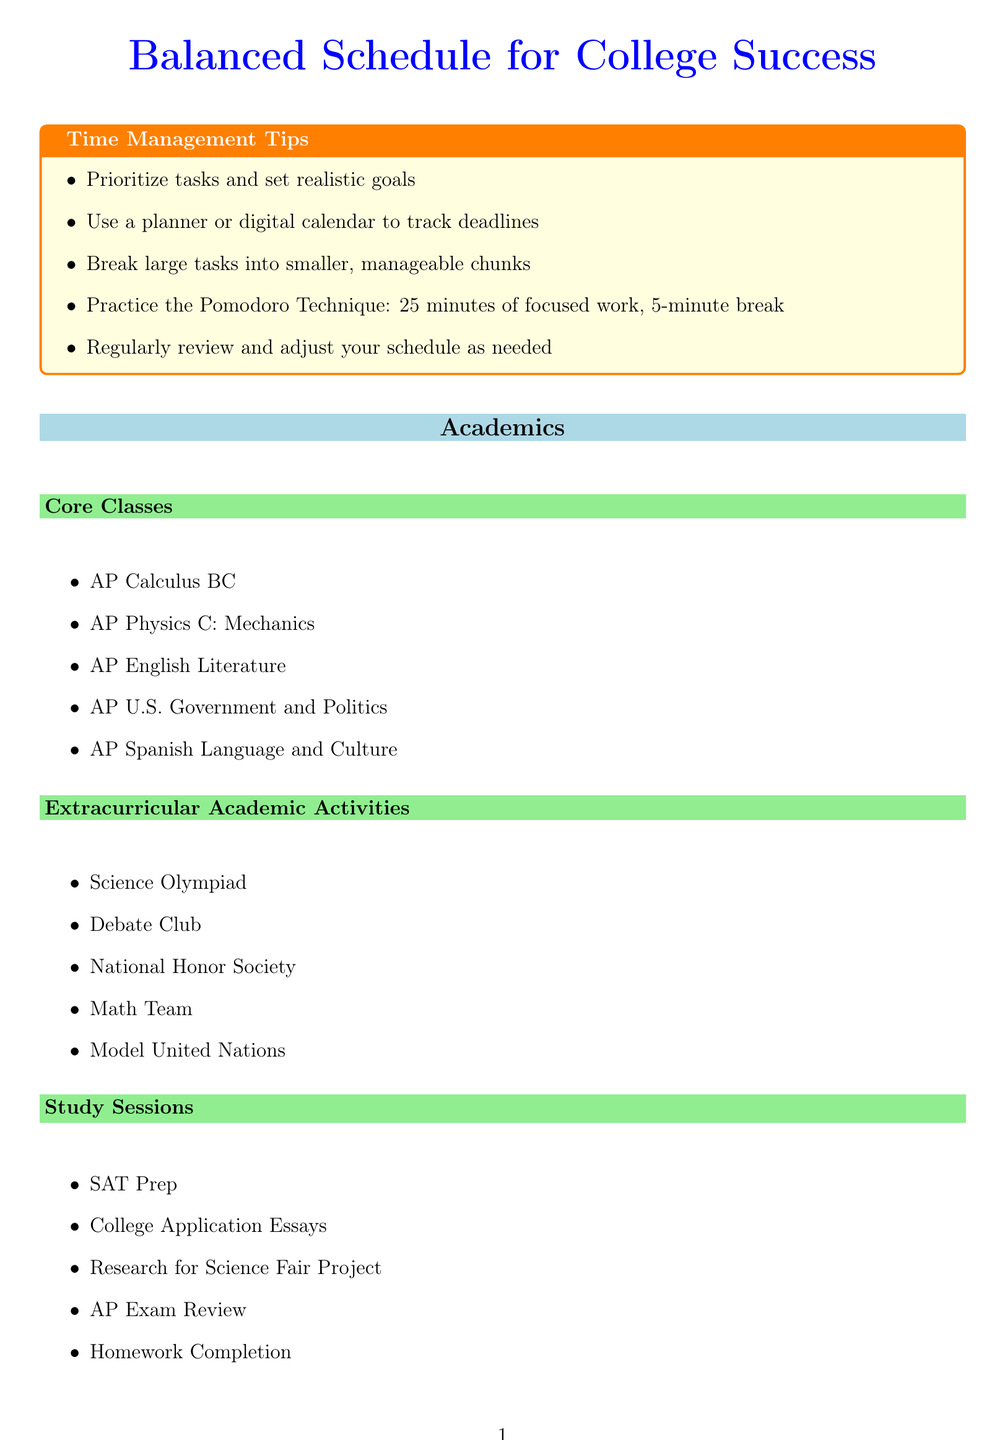What are the core classes listed? The core classes are specified under the Academics section and include five subjects.
Answer: AP Calculus BC, AP Physics C: Mechanics, AP English Literature, AP U.S. Government and Politics, AP Spanish Language and Culture How many categories are in the personal activities section? The personal activities section consists of Leadership, Community Service, Sports and Fitness, and Hobbies and Interests, totaling four categories.
Answer: 4 What activity is included in the Mental Health self-care routines? The Mental Health section outlines several activities, one of which is specifically listed.
Answer: Meditation and Mindfulness What is one extracurricular academic activity listed? One of the extracurricular academic activities can be chosen from a set of five items in the document.
Answer: Science Olympiad Which self-care routine falls under Physical Health? The Physical Health category contains various activities aimed at maintaining physical wellness.
Answer: 8 Hours of Sleep How many hours of sleep are recommended? The specific recommendation for sleep is mentioned in the Physical Health routines.
Answer: 8 Hours What position does the Student Council President hold in personal activities? This role identifies a specific leadership position listed in the personal activities section.
Answer: Leadership Name one hobby listed in the Hobbies and Interests section. The hobbies are detailed in a sub-section listing several activities, one of which can be selected.
Answer: Piano Lessons What is the total number of study sessions categories? The document details one type of study sessions category within the Academics section.
Answer: 1 